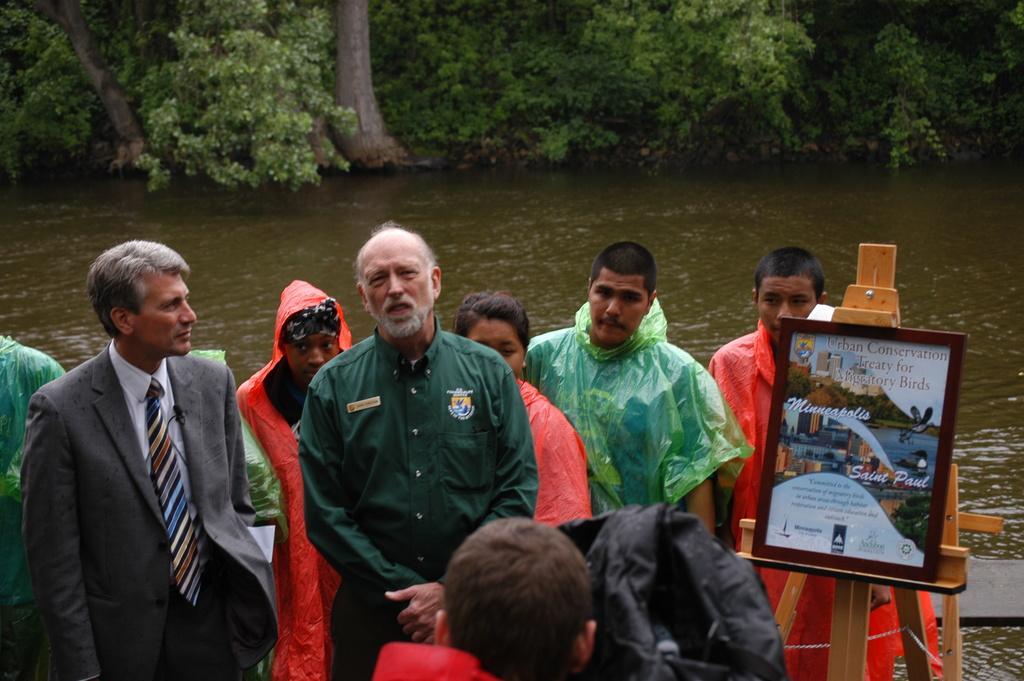Describe this image in one or two sentences. In the foreground of this image, there is a man´s head and a black color object. In the background, there are men and a woman standing. Few are in coats and remaining are wearing rainy coats. On the right, there is a frame on a painting stand. In the background there is water and the trees. 